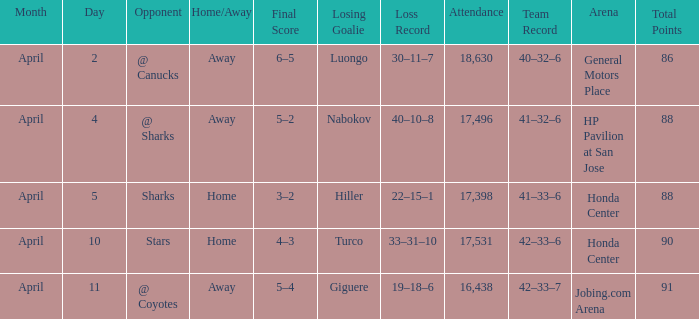Which Attendance has more than 90 points? 16438.0. 